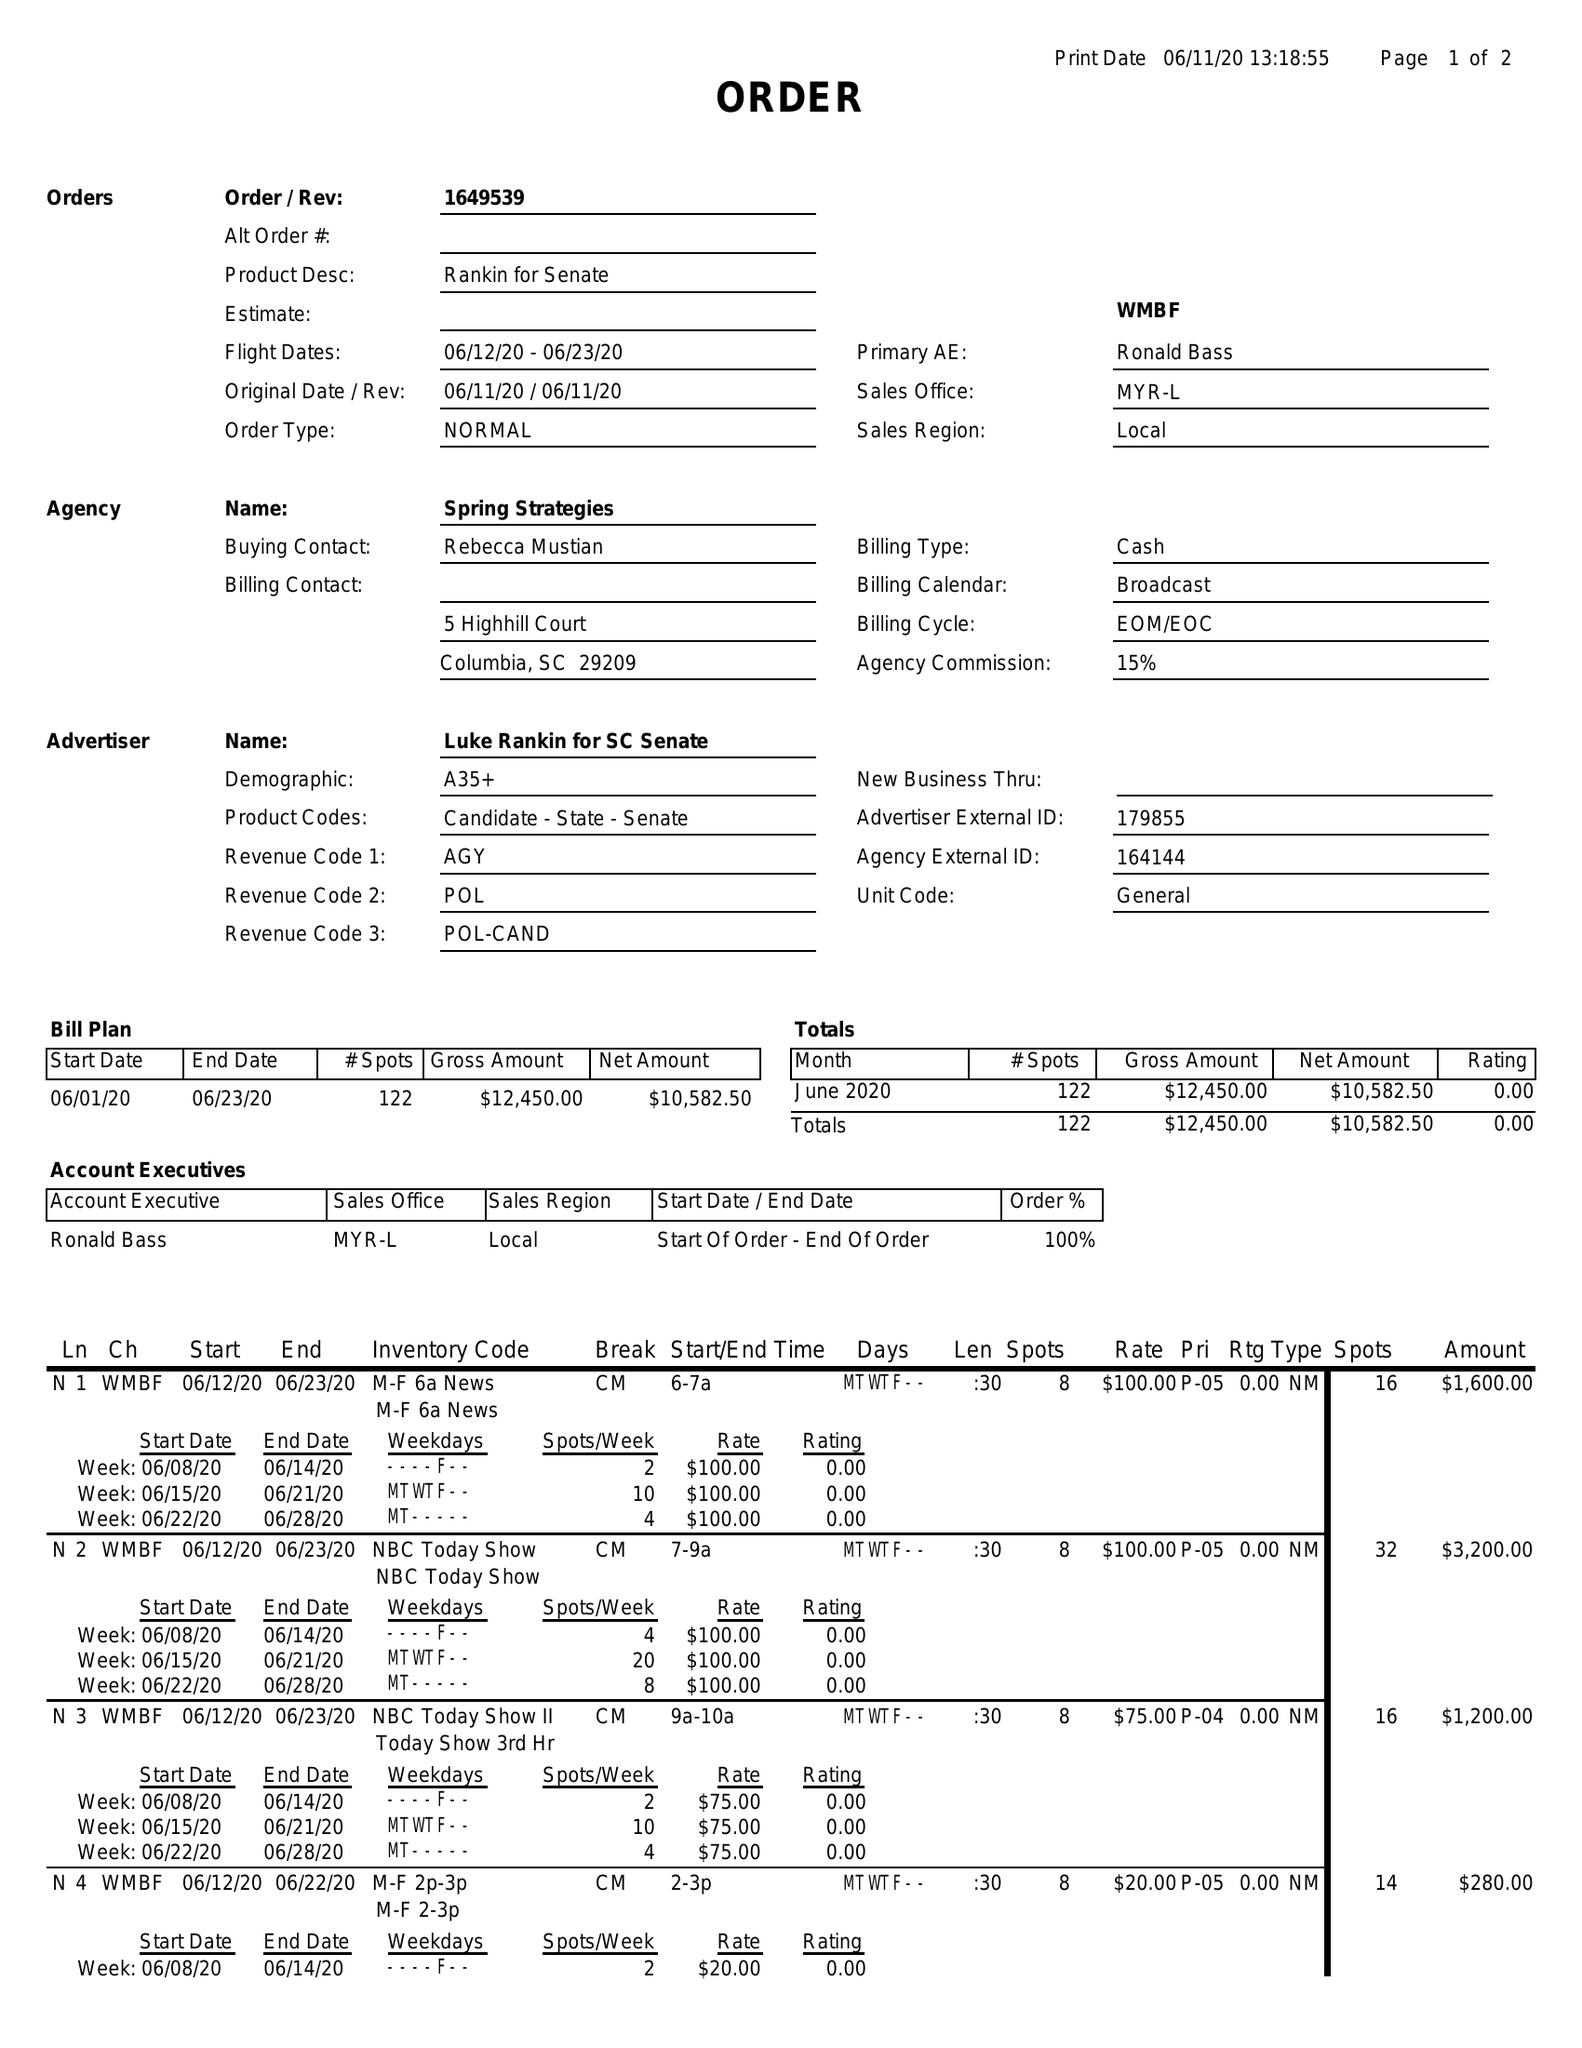What is the value for the flight_to?
Answer the question using a single word or phrase. 06/23/20 